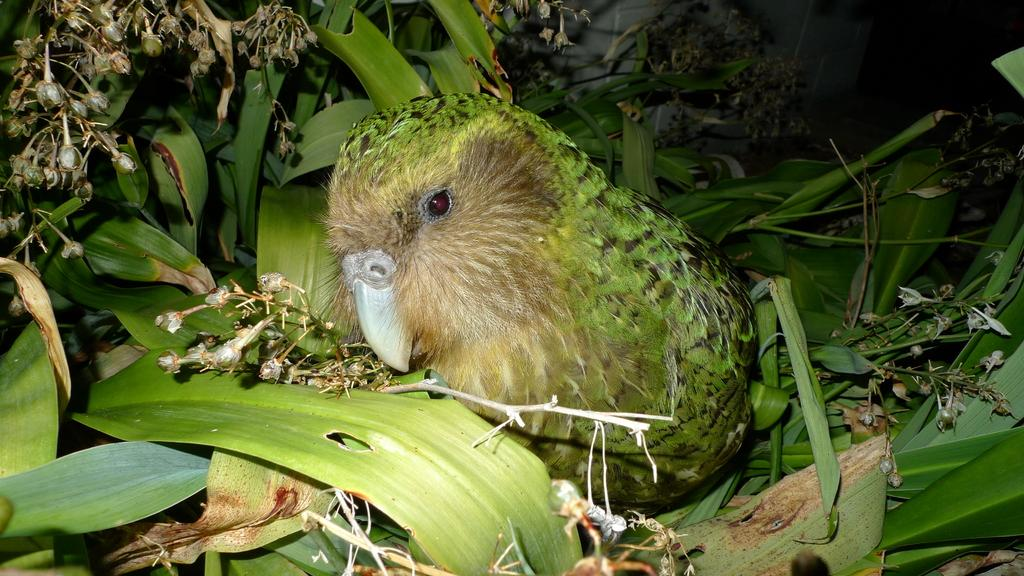What type of animal can be seen in the image? There is a bird in the image. What color is the bird? The bird is green in color. What other living organisms are present in the image? There are plants with leaves in the image. What stage of growth are the flowers in the image? There is a bunch of flower buds in the image. What type of nail is being used to hang the bird in the image? There is no nail present in the image, and the bird is not hanging. 